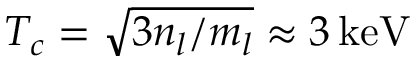<formula> <loc_0><loc_0><loc_500><loc_500>T _ { c } = \sqrt { 3 n _ { l } / m _ { l } } \approx 3 \, k e V</formula> 